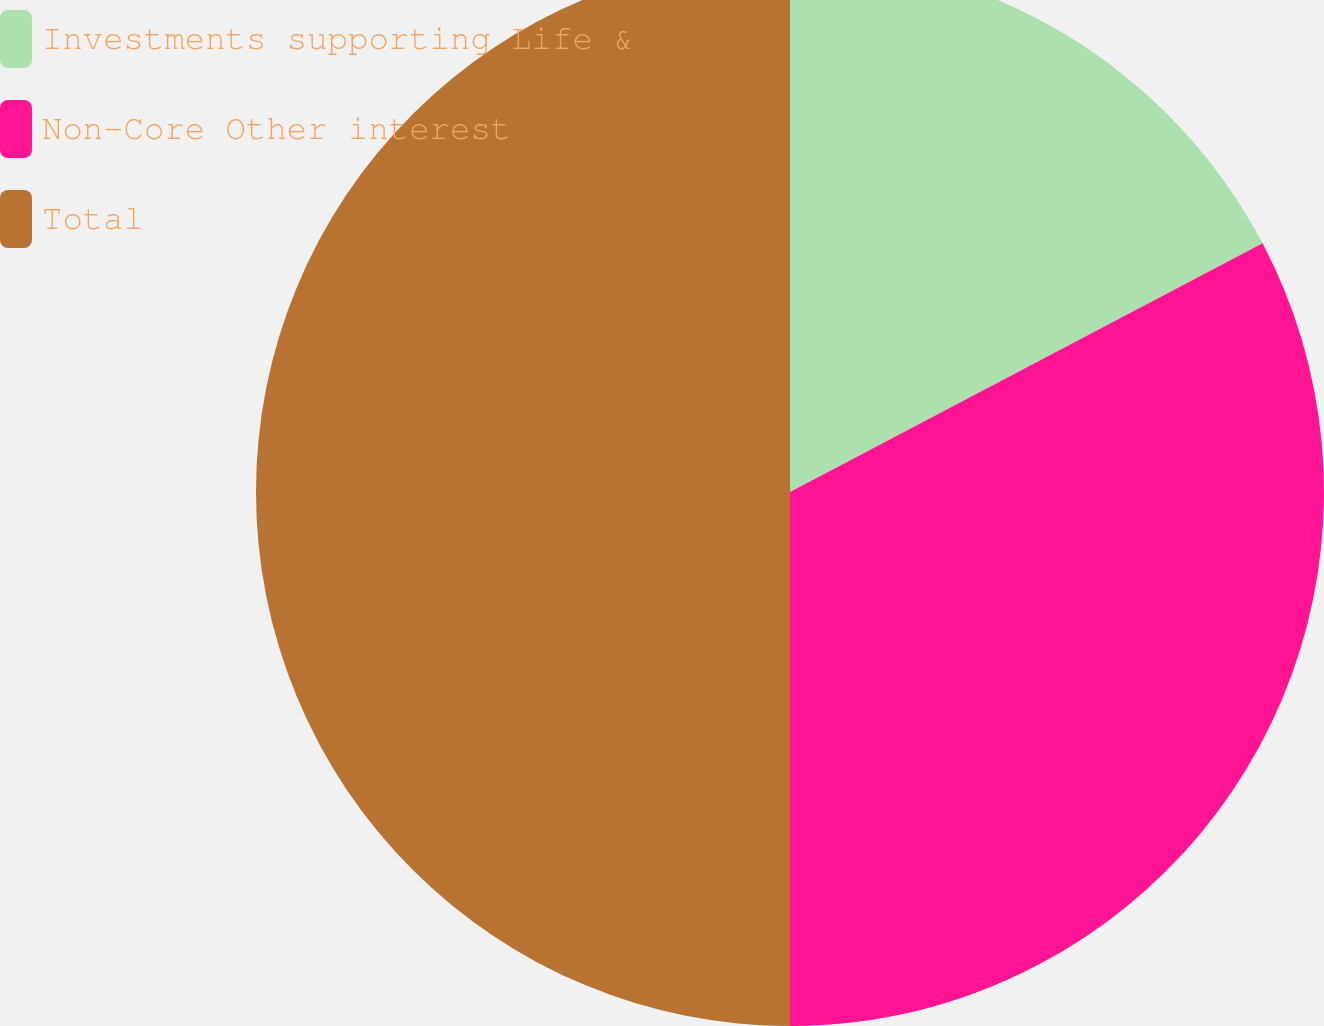<chart> <loc_0><loc_0><loc_500><loc_500><pie_chart><fcel>Investments supporting Life &<fcel>Non-Core Other interest<fcel>Total<nl><fcel>17.29%<fcel>32.71%<fcel>50.0%<nl></chart> 